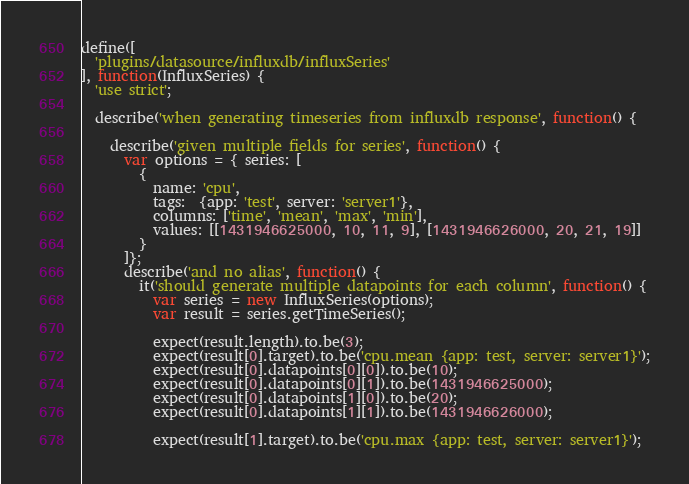Convert code to text. <code><loc_0><loc_0><loc_500><loc_500><_JavaScript_>define([
  'plugins/datasource/influxdb/influxSeries'
], function(InfluxSeries) {
  'use strict';

  describe('when generating timeseries from influxdb response', function() {

    describe('given multiple fields for series', function() {
      var options = { series: [
        {
          name: 'cpu',
          tags:  {app: 'test', server: 'server1'},
          columns: ['time', 'mean', 'max', 'min'],
          values: [[1431946625000, 10, 11, 9], [1431946626000, 20, 21, 19]]
        }
      ]};
      describe('and no alias', function() {
        it('should generate multiple datapoints for each column', function() {
          var series = new InfluxSeries(options);
          var result = series.getTimeSeries();

          expect(result.length).to.be(3);
          expect(result[0].target).to.be('cpu.mean {app: test, server: server1}');
          expect(result[0].datapoints[0][0]).to.be(10);
          expect(result[0].datapoints[0][1]).to.be(1431946625000);
          expect(result[0].datapoints[1][0]).to.be(20);
          expect(result[0].datapoints[1][1]).to.be(1431946626000);

          expect(result[1].target).to.be('cpu.max {app: test, server: server1}');</code> 